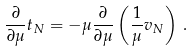<formula> <loc_0><loc_0><loc_500><loc_500>\frac { \partial } { \partial \mu } t _ { N } = - \mu \frac { \partial } { \partial \mu } \left ( \frac { 1 } { \mu } v _ { N } \right ) \, .</formula> 